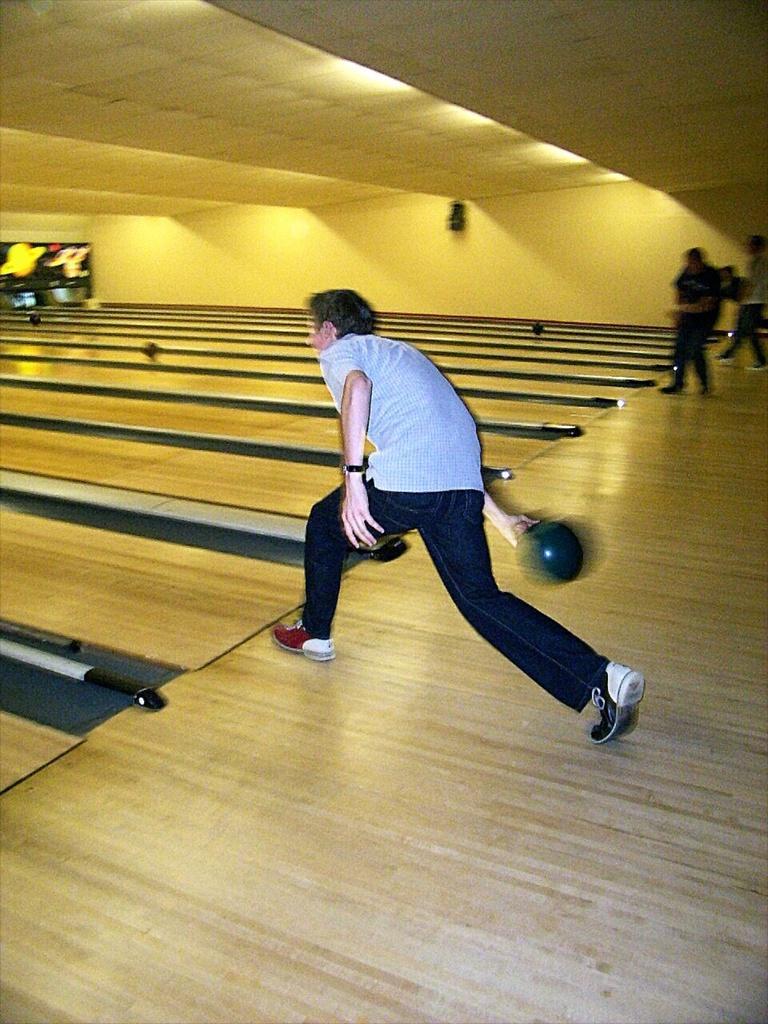Can you describe this image briefly? In this image there is a person holding a ball in his hand. Right side there are few persons standing on the floor. There are few balls on the floor. Top of image there are few lights attached to the roof. 